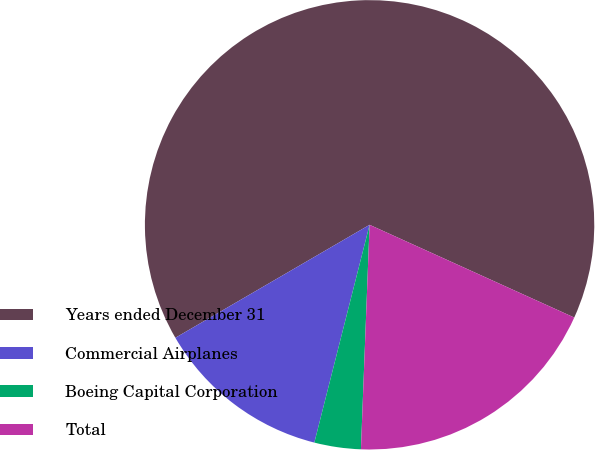Convert chart to OTSL. <chart><loc_0><loc_0><loc_500><loc_500><pie_chart><fcel>Years ended December 31<fcel>Commercial Airplanes<fcel>Boeing Capital Corporation<fcel>Total<nl><fcel>65.15%<fcel>12.66%<fcel>3.34%<fcel>18.84%<nl></chart> 